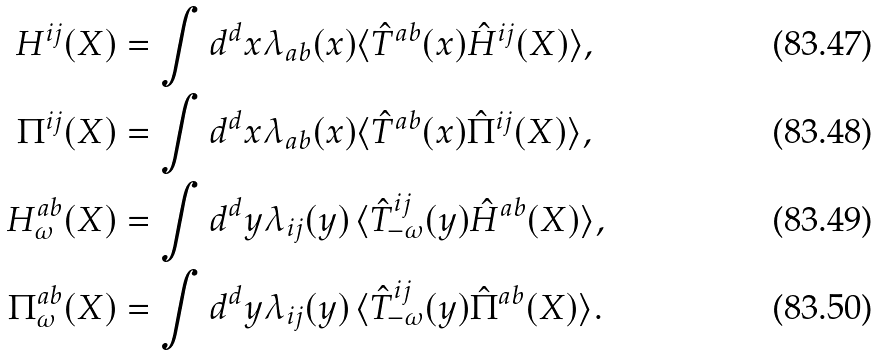<formula> <loc_0><loc_0><loc_500><loc_500>H ^ { i j } ( X ) & = \int d ^ { d } x \lambda _ { a b } ( x ) \langle \hat { T } ^ { a b } ( x ) \hat { H } ^ { i j } ( X ) \rangle , \\ \Pi ^ { i j } ( X ) & = \int d ^ { d } x \lambda _ { a b } ( x ) \langle \hat { T } ^ { a b } ( x ) \hat { \Pi } ^ { i j } ( X ) \rangle , \\ H _ { \omega } ^ { a b } ( X ) & = \int d ^ { d } y \lambda _ { i j } ( y ) \, \langle \hat { T } _ { - \omega } ^ { i j } ( y ) \hat { H } ^ { a b } ( X ) \rangle , \\ \Pi _ { \omega } ^ { a b } ( X ) & = \int d ^ { d } y \lambda _ { i j } ( y ) \, \langle \hat { T } _ { - \omega } ^ { i j } ( y ) \hat { \Pi } ^ { a b } ( X ) \rangle .</formula> 